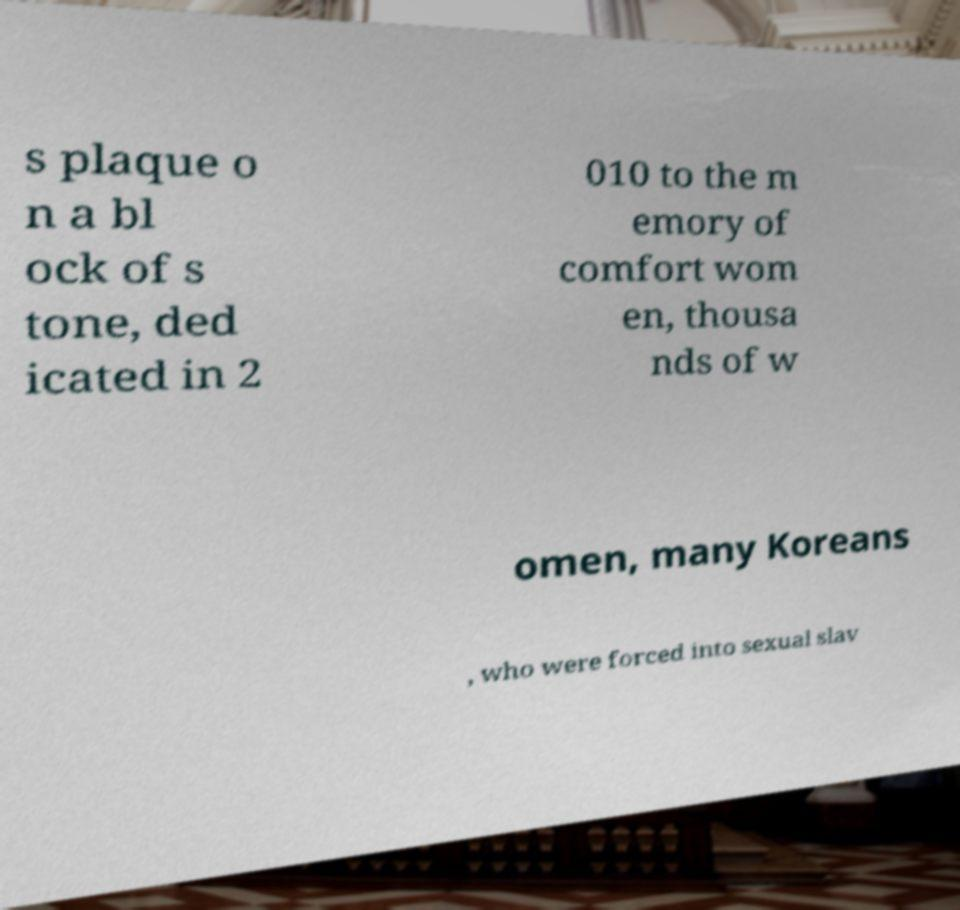There's text embedded in this image that I need extracted. Can you transcribe it verbatim? s plaque o n a bl ock of s tone, ded icated in 2 010 to the m emory of comfort wom en, thousa nds of w omen, many Koreans , who were forced into sexual slav 